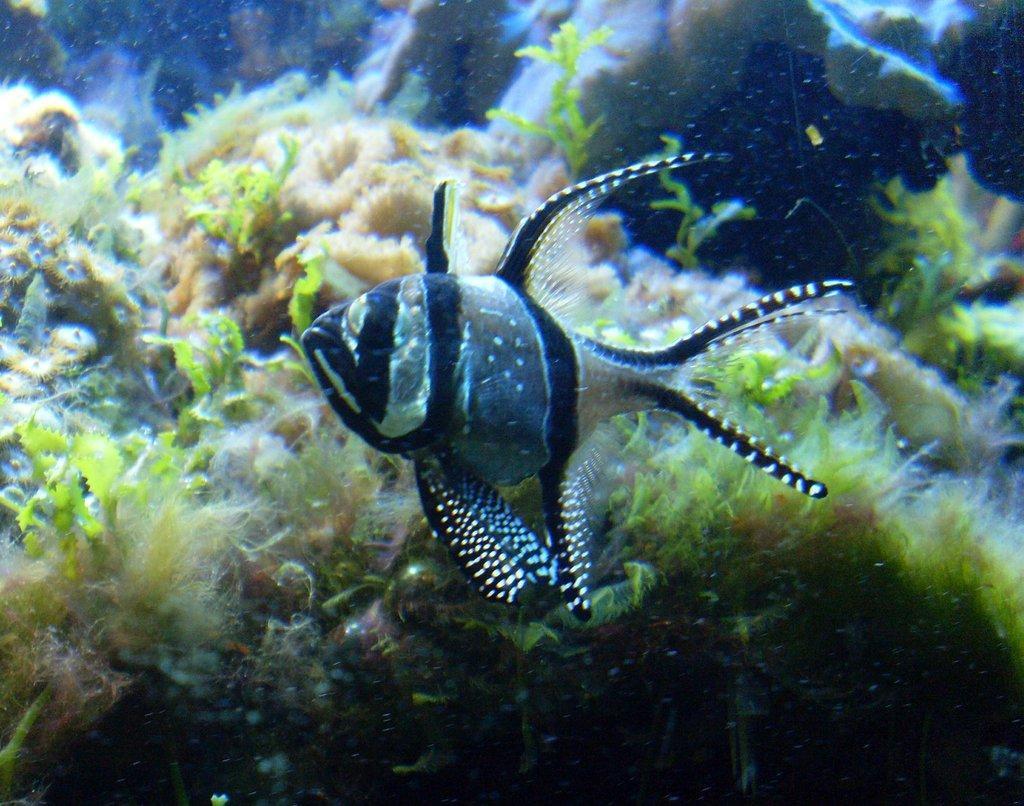Could you give a brief overview of what you see in this image? This is a water body and here we can see a fish and there are small plants. 